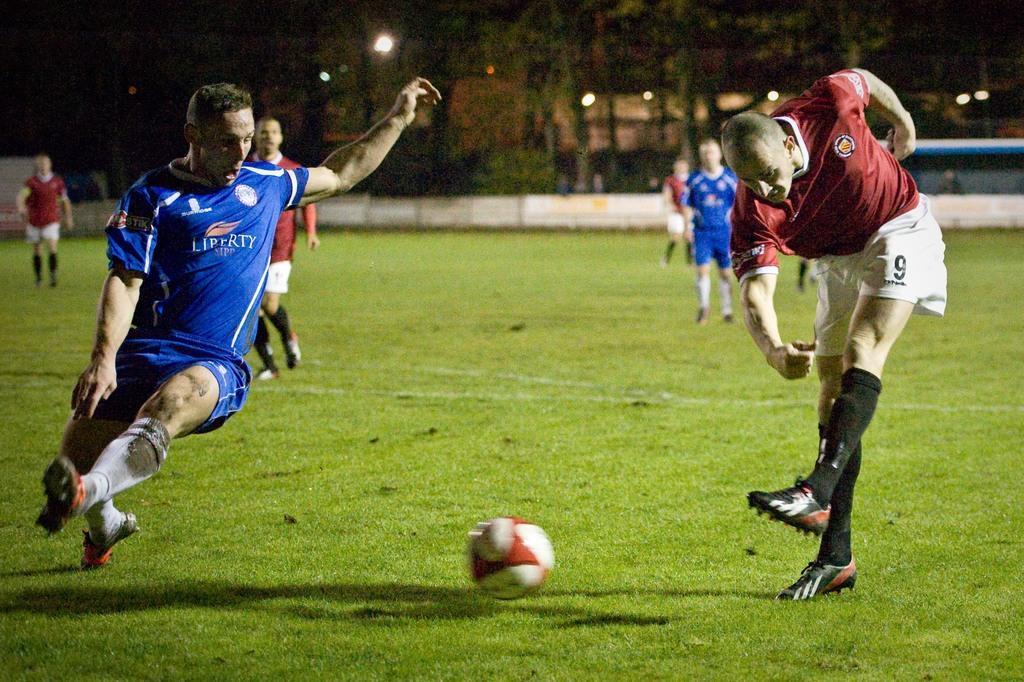Can you describe this image briefly? In this image on a ground players are playing football. In the middle there is a football. In the background there are trees, buildings, lights. There is boundary around the field. 